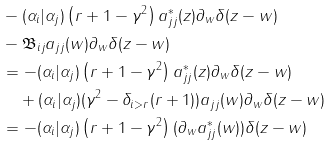<formula> <loc_0><loc_0><loc_500><loc_500>& - ( \alpha _ { i } | \alpha _ { j } ) \left ( r + 1 - \gamma ^ { 2 } \right ) a _ { j j } ^ { * } ( z ) \partial _ { w } \delta ( z - w ) \\ & - \mathfrak { B } _ { i j } a _ { j j } ( w ) \partial _ { w } \delta ( z - w ) \\ & = - ( \alpha _ { i } | \alpha _ { j } ) \left ( r + 1 - \gamma ^ { 2 } \right ) a _ { j j } ^ { * } ( z ) \partial _ { w } \delta ( z - w ) \\ & \quad + ( \alpha _ { i } | \alpha _ { j } ) ( \gamma ^ { 2 } - \delta _ { i > r } ( r + 1 ) ) a _ { j j } ( w ) \partial _ { w } \delta ( z - w ) \\ & = - ( \alpha _ { i } | \alpha _ { j } ) \left ( r + 1 - \gamma ^ { 2 } \right ) ( \partial _ { w } a _ { j j } ^ { * } ( w ) ) \delta ( z - w )</formula> 